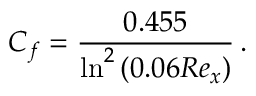Convert formula to latex. <formula><loc_0><loc_0><loc_500><loc_500>C _ { f } = \frac { 0 . 4 5 5 } { \ln ^ { 2 } { \left ( 0 . 0 6 R e _ { x } \right ) } } \, .</formula> 